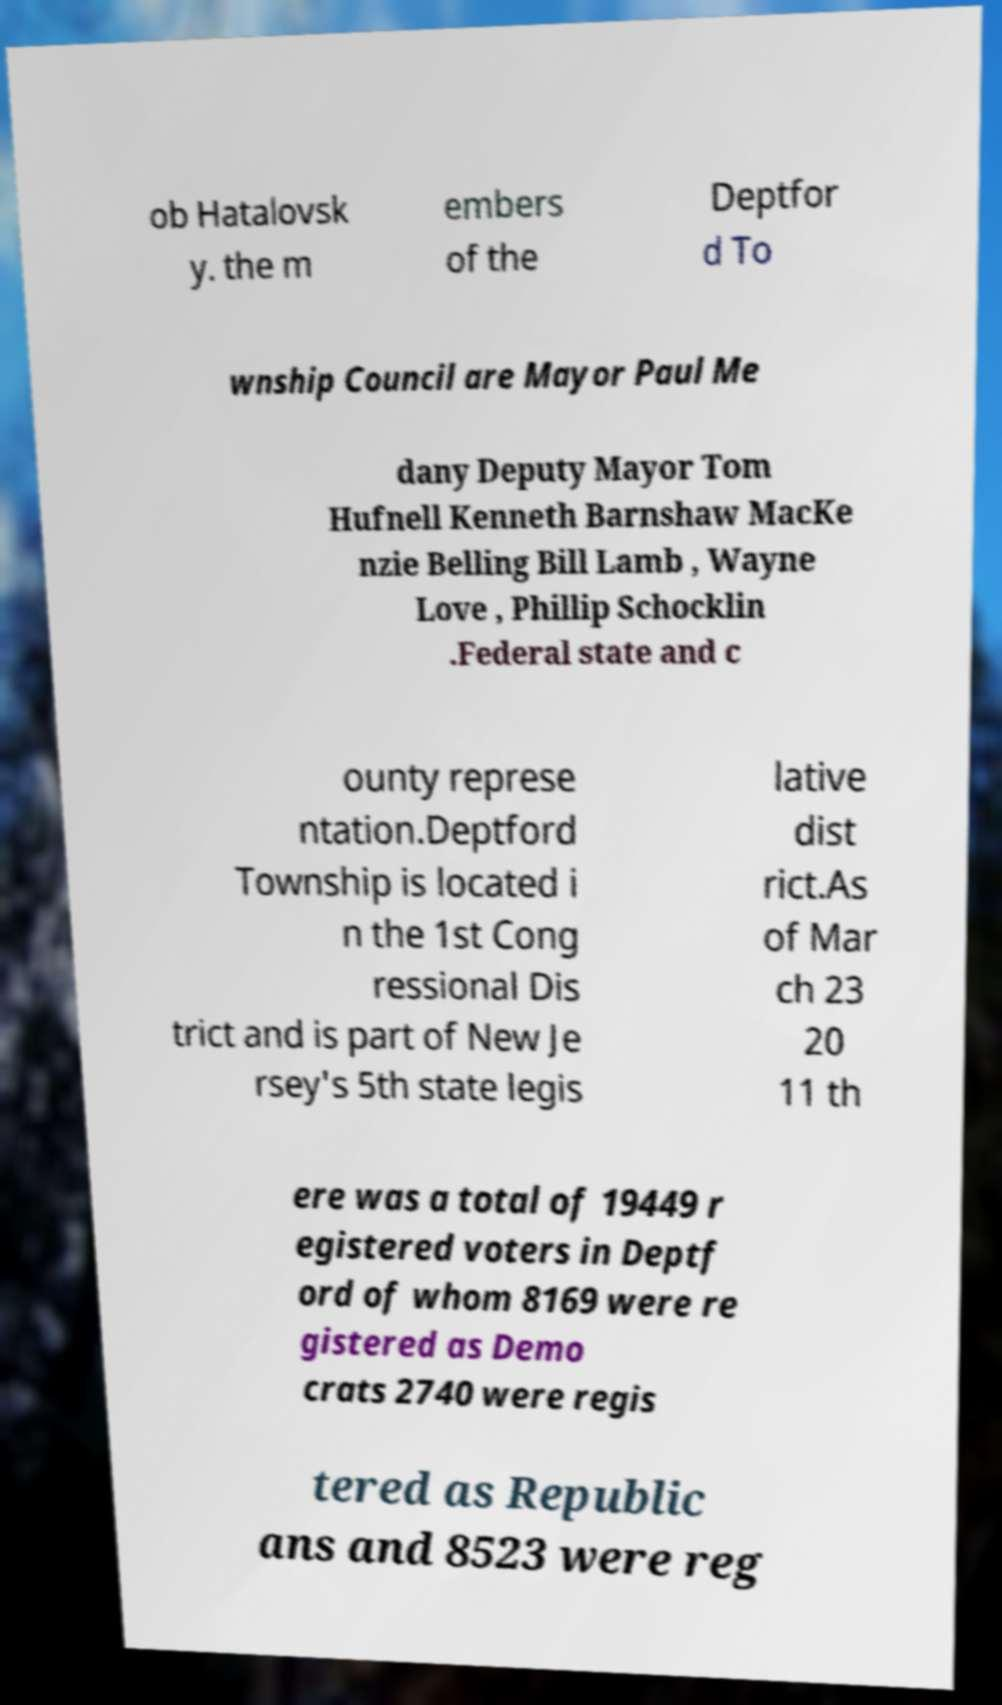What messages or text are displayed in this image? I need them in a readable, typed format. ob Hatalovsk y. the m embers of the Deptfor d To wnship Council are Mayor Paul Me dany Deputy Mayor Tom Hufnell Kenneth Barnshaw MacKe nzie Belling Bill Lamb , Wayne Love , Phillip Schocklin .Federal state and c ounty represe ntation.Deptford Township is located i n the 1st Cong ressional Dis trict and is part of New Je rsey's 5th state legis lative dist rict.As of Mar ch 23 20 11 th ere was a total of 19449 r egistered voters in Deptf ord of whom 8169 were re gistered as Demo crats 2740 were regis tered as Republic ans and 8523 were reg 